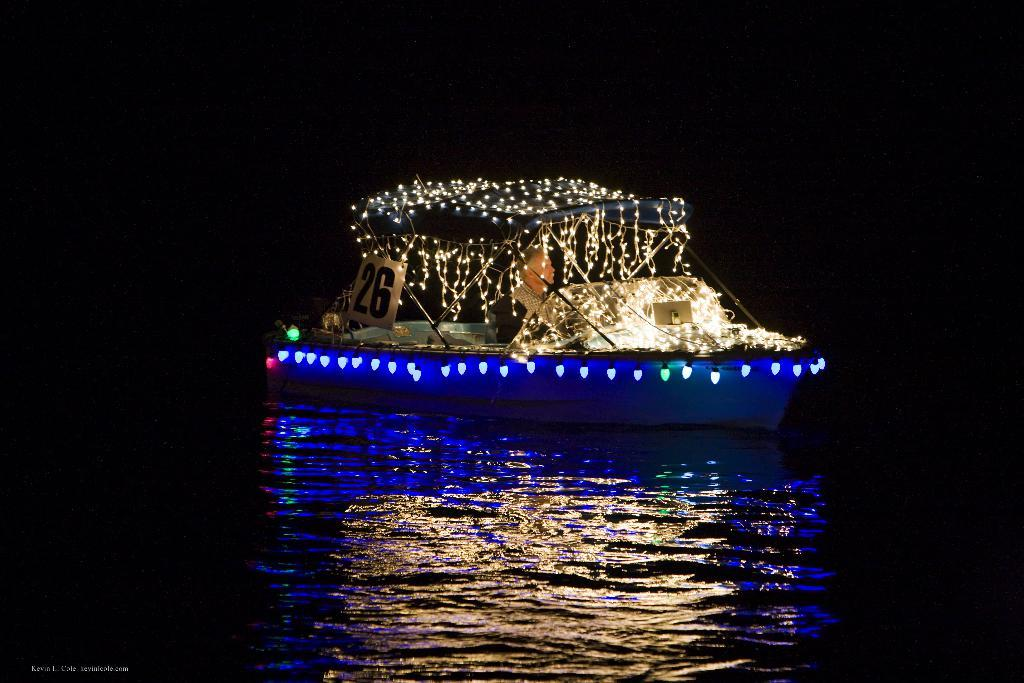What is the main subject of the image? The main subject of the image is a boat. How is the boat decorated? The boat is decorated with lights. What is the setting of the image? There is water in the image. What is the son's idea for decorating the boat in the image? There is no information about a son or their idea for decorating the boat in the image. 